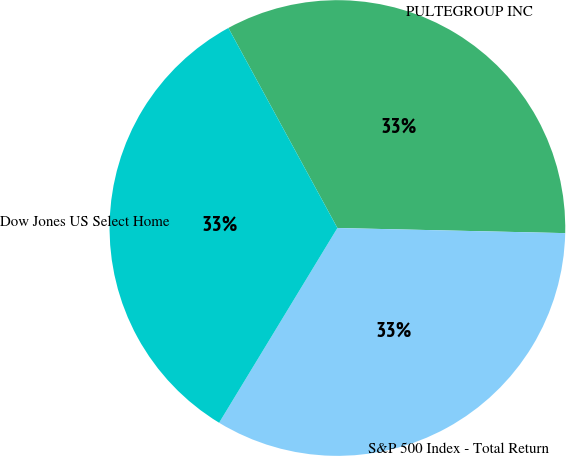<chart> <loc_0><loc_0><loc_500><loc_500><pie_chart><fcel>PULTEGROUP INC<fcel>S&P 500 Index - Total Return<fcel>Dow Jones US Select Home<nl><fcel>33.3%<fcel>33.33%<fcel>33.37%<nl></chart> 